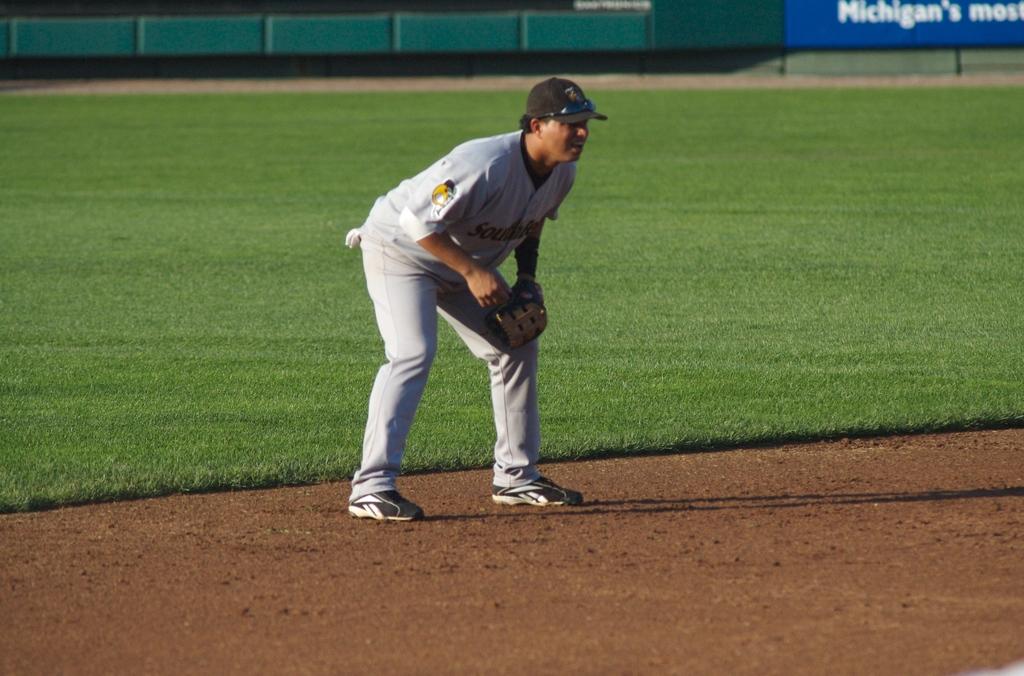What state is this likely in?
Your response must be concise. Michigan. 